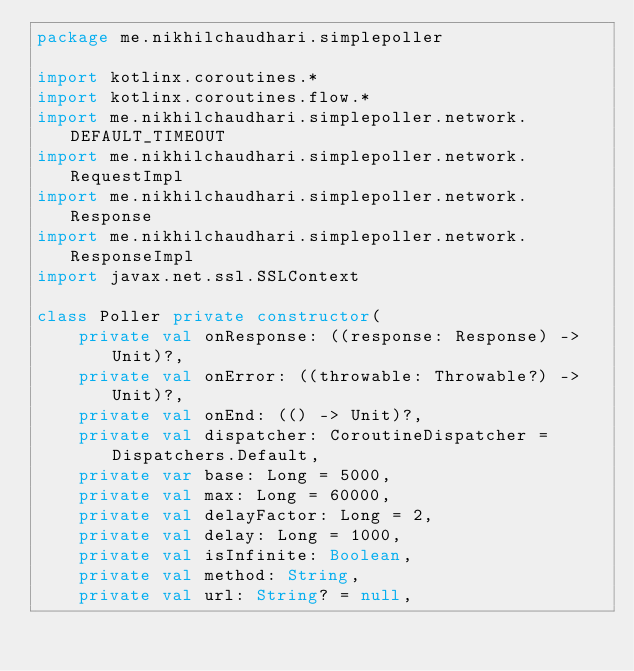Convert code to text. <code><loc_0><loc_0><loc_500><loc_500><_Kotlin_>package me.nikhilchaudhari.simplepoller

import kotlinx.coroutines.*
import kotlinx.coroutines.flow.*
import me.nikhilchaudhari.simplepoller.network.DEFAULT_TIMEOUT
import me.nikhilchaudhari.simplepoller.network.RequestImpl
import me.nikhilchaudhari.simplepoller.network.Response
import me.nikhilchaudhari.simplepoller.network.ResponseImpl
import javax.net.ssl.SSLContext

class Poller private constructor(
    private val onResponse: ((response: Response) -> Unit)?,
    private val onError: ((throwable: Throwable?) -> Unit)?,
    private val onEnd: (() -> Unit)?,
    private val dispatcher: CoroutineDispatcher = Dispatchers.Default,
    private var base: Long = 5000,
    private val max: Long = 60000,
    private val delayFactor: Long = 2,
    private val delay: Long = 1000,
    private val isInfinite: Boolean,
    private val method: String,
    private val url: String? = null,</code> 